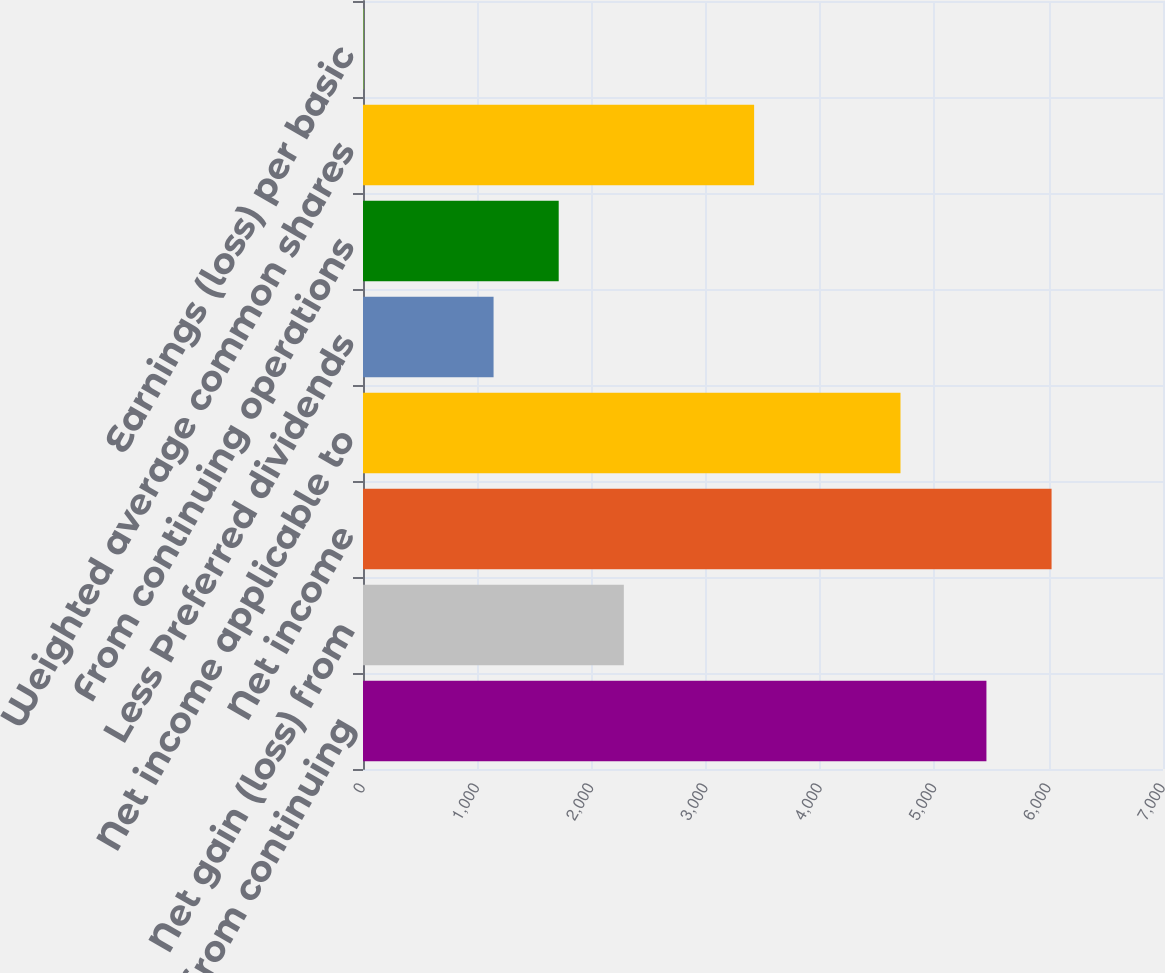Convert chart to OTSL. <chart><loc_0><loc_0><loc_500><loc_500><bar_chart><fcel>Income from continuing<fcel>Net gain (loss) from<fcel>Net income<fcel>Net income applicable to<fcel>Less Preferred dividends<fcel>From continuing operations<fcel>Weighted average common shares<fcel>Earnings (loss) per basic<nl><fcel>5455<fcel>2282.4<fcel>6024.94<fcel>4703<fcel>1142.52<fcel>1712.46<fcel>3422.28<fcel>2.64<nl></chart> 